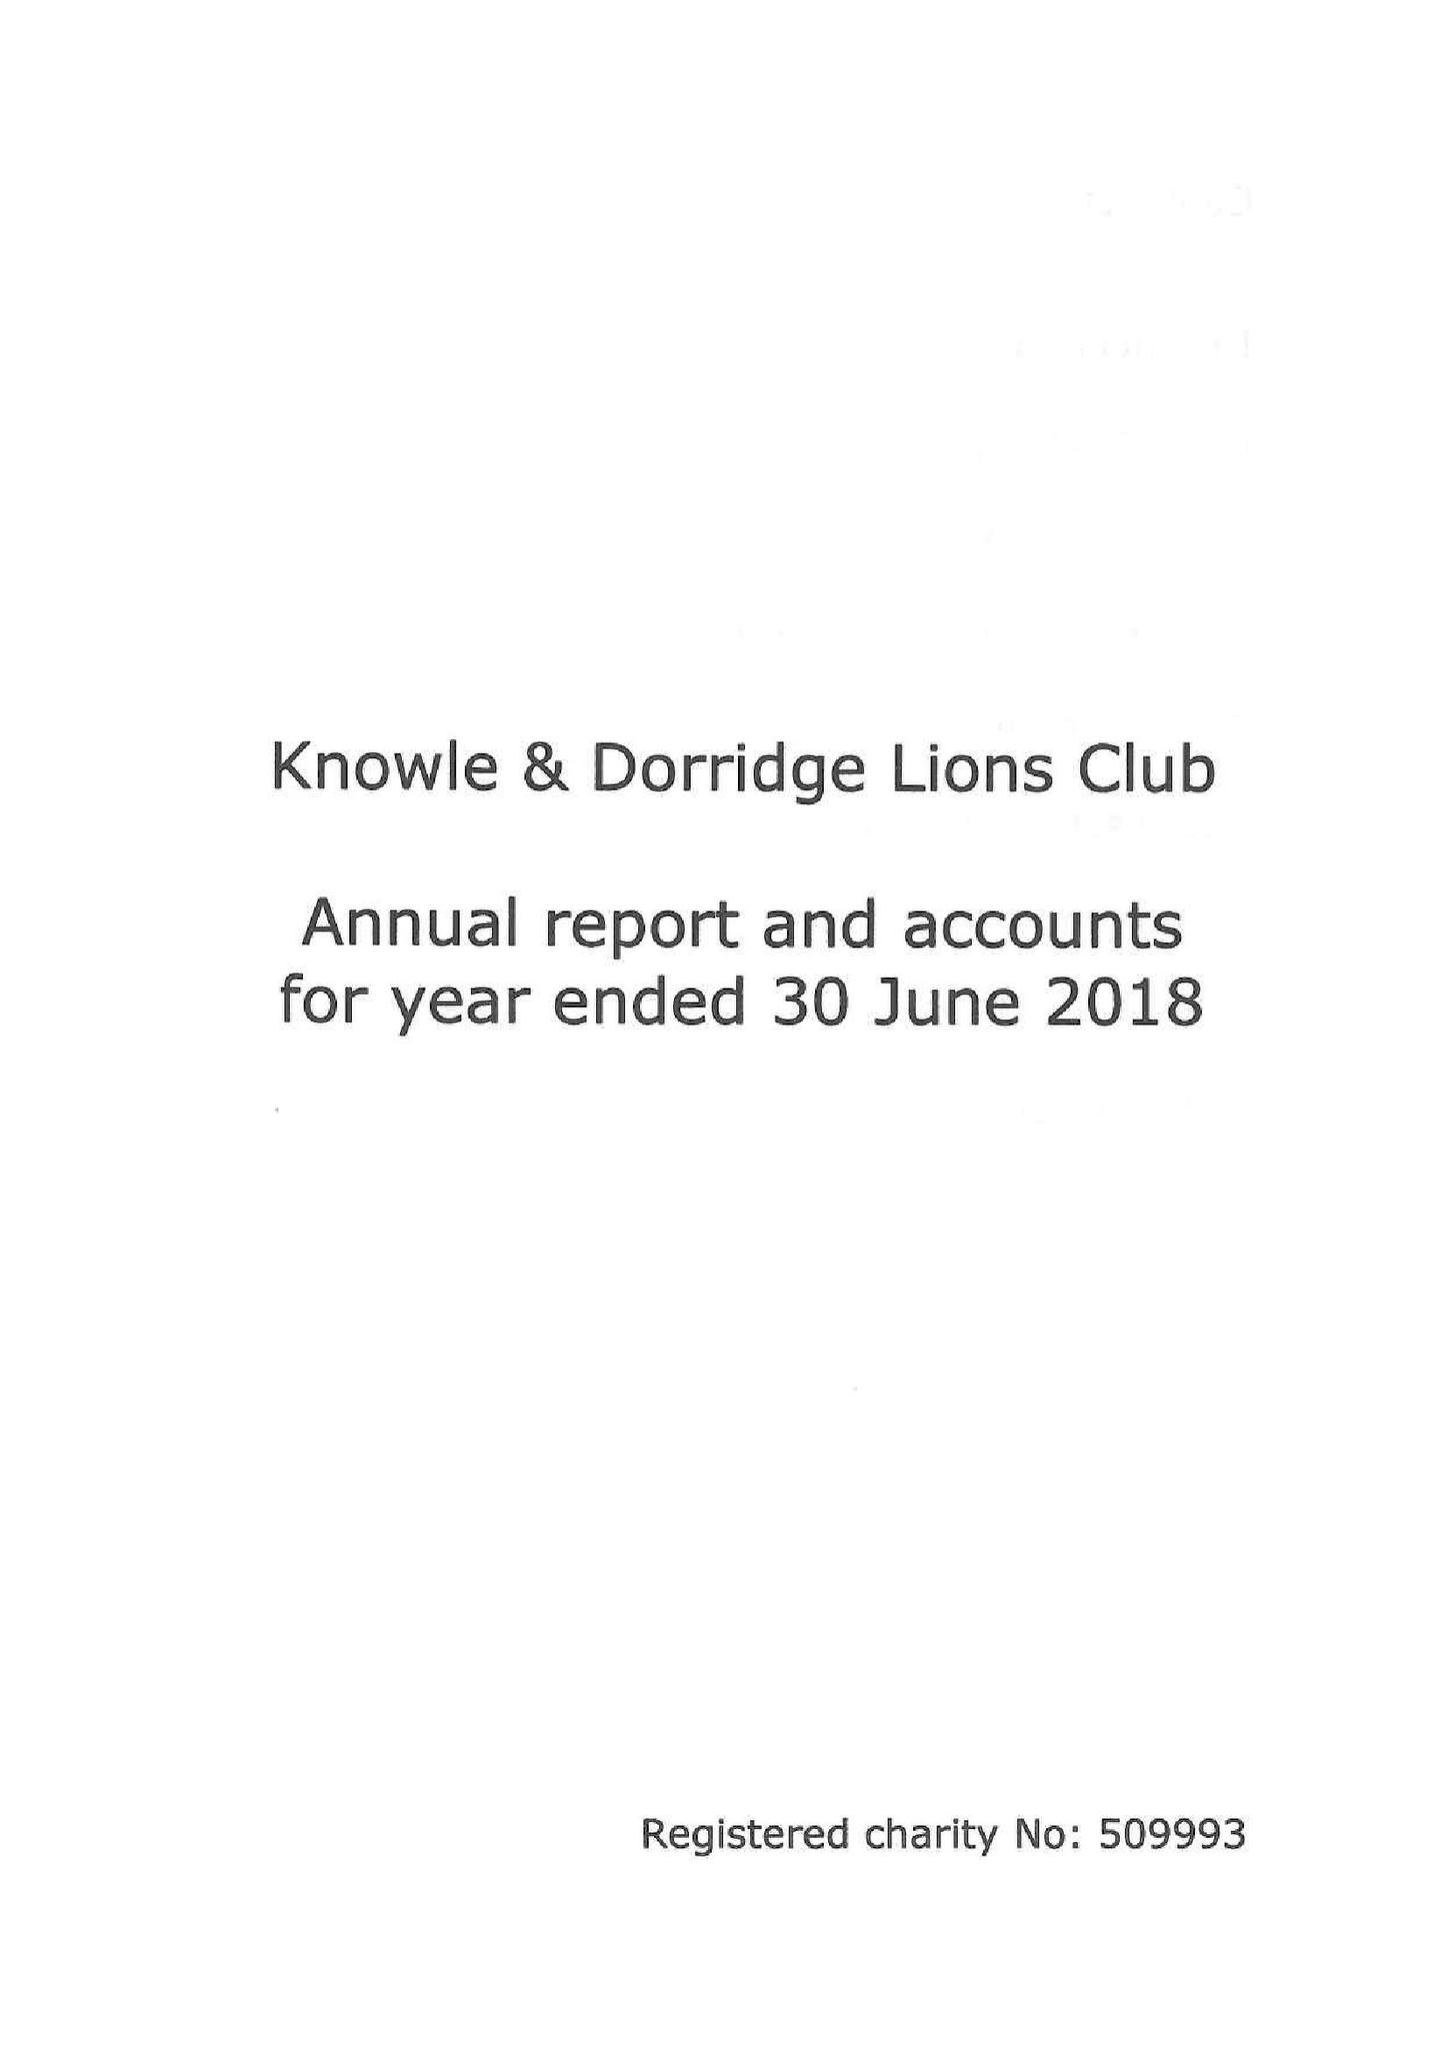What is the value for the charity_name?
Answer the question using a single word or phrase. Knowle and Dorridge Lions Club Charity Trust Fund 